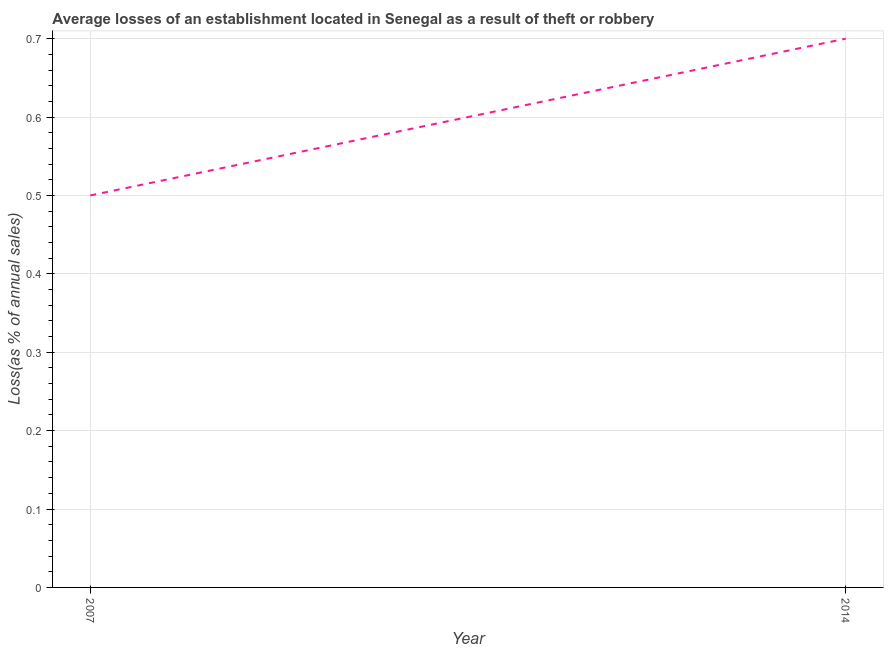What is the losses due to theft in 2014?
Keep it short and to the point. 0.7. Across all years, what is the minimum losses due to theft?
Provide a succinct answer. 0.5. In which year was the losses due to theft minimum?
Your answer should be compact. 2007. What is the sum of the losses due to theft?
Your answer should be compact. 1.2. What is the difference between the losses due to theft in 2007 and 2014?
Offer a terse response. -0.2. What is the ratio of the losses due to theft in 2007 to that in 2014?
Make the answer very short. 0.71. How many lines are there?
Ensure brevity in your answer.  1. How many years are there in the graph?
Give a very brief answer. 2. What is the difference between two consecutive major ticks on the Y-axis?
Offer a very short reply. 0.1. Are the values on the major ticks of Y-axis written in scientific E-notation?
Offer a very short reply. No. Does the graph contain grids?
Offer a very short reply. Yes. What is the title of the graph?
Your answer should be compact. Average losses of an establishment located in Senegal as a result of theft or robbery. What is the label or title of the X-axis?
Provide a succinct answer. Year. What is the label or title of the Y-axis?
Keep it short and to the point. Loss(as % of annual sales). What is the Loss(as % of annual sales) of 2007?
Your answer should be compact. 0.5. What is the Loss(as % of annual sales) in 2014?
Offer a terse response. 0.7. What is the difference between the Loss(as % of annual sales) in 2007 and 2014?
Make the answer very short. -0.2. What is the ratio of the Loss(as % of annual sales) in 2007 to that in 2014?
Keep it short and to the point. 0.71. 